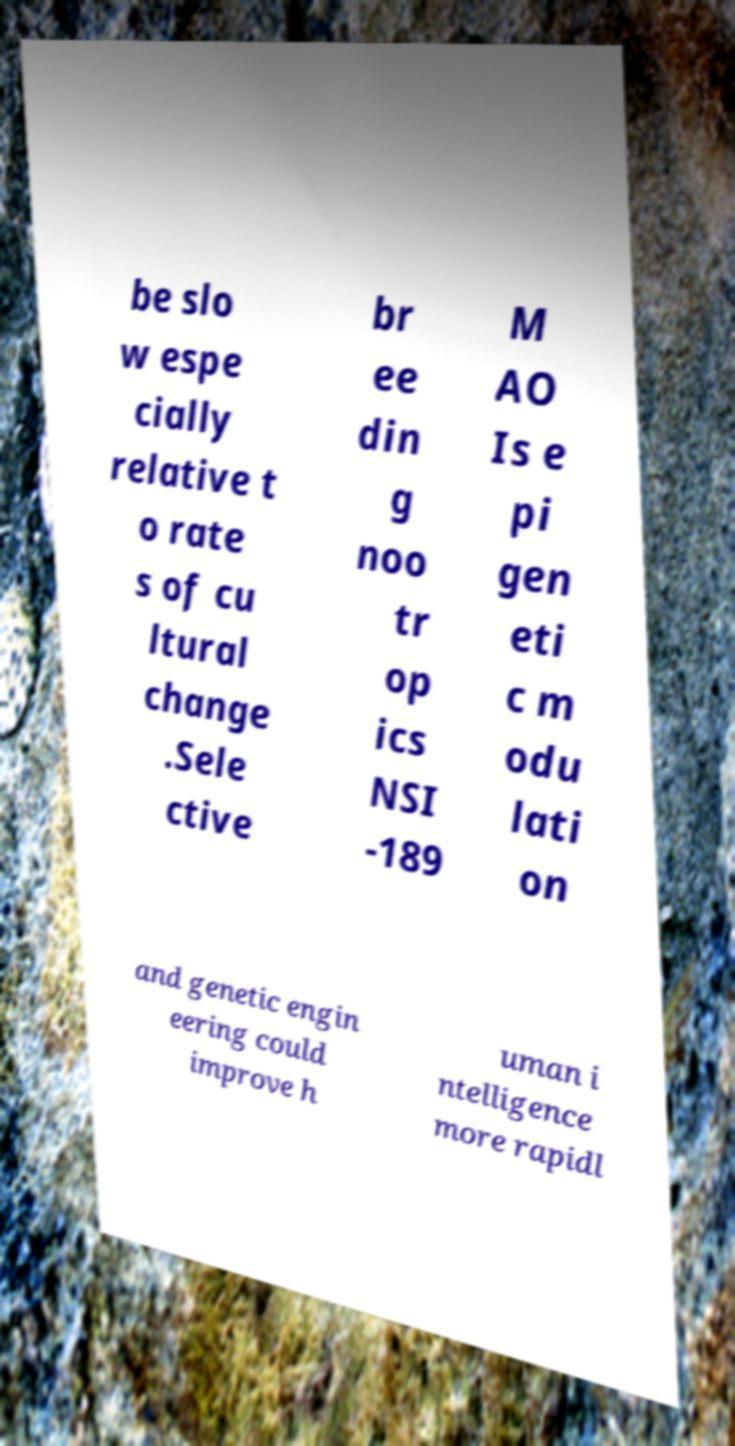Could you assist in decoding the text presented in this image and type it out clearly? be slo w espe cially relative t o rate s of cu ltural change .Sele ctive br ee din g noo tr op ics NSI -189 M AO Is e pi gen eti c m odu lati on and genetic engin eering could improve h uman i ntelligence more rapidl 